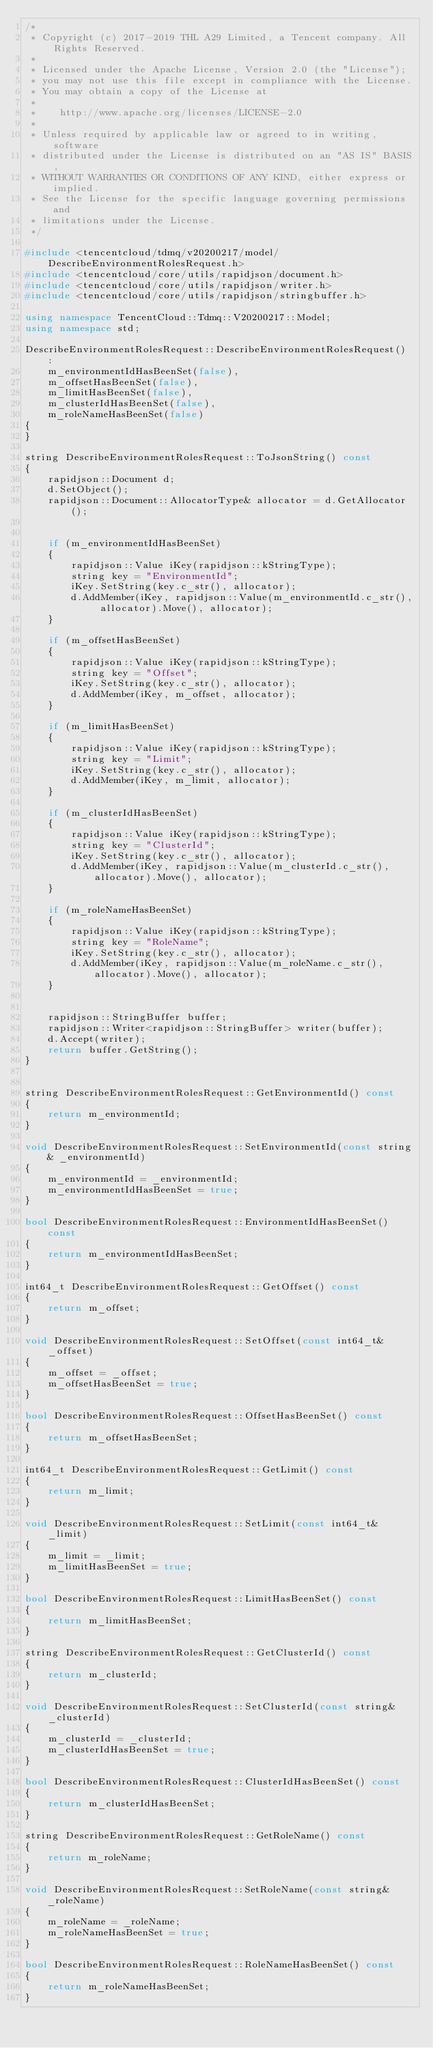<code> <loc_0><loc_0><loc_500><loc_500><_C++_>/*
 * Copyright (c) 2017-2019 THL A29 Limited, a Tencent company. All Rights Reserved.
 *
 * Licensed under the Apache License, Version 2.0 (the "License");
 * you may not use this file except in compliance with the License.
 * You may obtain a copy of the License at
 *
 *    http://www.apache.org/licenses/LICENSE-2.0
 *
 * Unless required by applicable law or agreed to in writing, software
 * distributed under the License is distributed on an "AS IS" BASIS,
 * WITHOUT WARRANTIES OR CONDITIONS OF ANY KIND, either express or implied.
 * See the License for the specific language governing permissions and
 * limitations under the License.
 */

#include <tencentcloud/tdmq/v20200217/model/DescribeEnvironmentRolesRequest.h>
#include <tencentcloud/core/utils/rapidjson/document.h>
#include <tencentcloud/core/utils/rapidjson/writer.h>
#include <tencentcloud/core/utils/rapidjson/stringbuffer.h>

using namespace TencentCloud::Tdmq::V20200217::Model;
using namespace std;

DescribeEnvironmentRolesRequest::DescribeEnvironmentRolesRequest() :
    m_environmentIdHasBeenSet(false),
    m_offsetHasBeenSet(false),
    m_limitHasBeenSet(false),
    m_clusterIdHasBeenSet(false),
    m_roleNameHasBeenSet(false)
{
}

string DescribeEnvironmentRolesRequest::ToJsonString() const
{
    rapidjson::Document d;
    d.SetObject();
    rapidjson::Document::AllocatorType& allocator = d.GetAllocator();


    if (m_environmentIdHasBeenSet)
    {
        rapidjson::Value iKey(rapidjson::kStringType);
        string key = "EnvironmentId";
        iKey.SetString(key.c_str(), allocator);
        d.AddMember(iKey, rapidjson::Value(m_environmentId.c_str(), allocator).Move(), allocator);
    }

    if (m_offsetHasBeenSet)
    {
        rapidjson::Value iKey(rapidjson::kStringType);
        string key = "Offset";
        iKey.SetString(key.c_str(), allocator);
        d.AddMember(iKey, m_offset, allocator);
    }

    if (m_limitHasBeenSet)
    {
        rapidjson::Value iKey(rapidjson::kStringType);
        string key = "Limit";
        iKey.SetString(key.c_str(), allocator);
        d.AddMember(iKey, m_limit, allocator);
    }

    if (m_clusterIdHasBeenSet)
    {
        rapidjson::Value iKey(rapidjson::kStringType);
        string key = "ClusterId";
        iKey.SetString(key.c_str(), allocator);
        d.AddMember(iKey, rapidjson::Value(m_clusterId.c_str(), allocator).Move(), allocator);
    }

    if (m_roleNameHasBeenSet)
    {
        rapidjson::Value iKey(rapidjson::kStringType);
        string key = "RoleName";
        iKey.SetString(key.c_str(), allocator);
        d.AddMember(iKey, rapidjson::Value(m_roleName.c_str(), allocator).Move(), allocator);
    }


    rapidjson::StringBuffer buffer;
    rapidjson::Writer<rapidjson::StringBuffer> writer(buffer);
    d.Accept(writer);
    return buffer.GetString();
}


string DescribeEnvironmentRolesRequest::GetEnvironmentId() const
{
    return m_environmentId;
}

void DescribeEnvironmentRolesRequest::SetEnvironmentId(const string& _environmentId)
{
    m_environmentId = _environmentId;
    m_environmentIdHasBeenSet = true;
}

bool DescribeEnvironmentRolesRequest::EnvironmentIdHasBeenSet() const
{
    return m_environmentIdHasBeenSet;
}

int64_t DescribeEnvironmentRolesRequest::GetOffset() const
{
    return m_offset;
}

void DescribeEnvironmentRolesRequest::SetOffset(const int64_t& _offset)
{
    m_offset = _offset;
    m_offsetHasBeenSet = true;
}

bool DescribeEnvironmentRolesRequest::OffsetHasBeenSet() const
{
    return m_offsetHasBeenSet;
}

int64_t DescribeEnvironmentRolesRequest::GetLimit() const
{
    return m_limit;
}

void DescribeEnvironmentRolesRequest::SetLimit(const int64_t& _limit)
{
    m_limit = _limit;
    m_limitHasBeenSet = true;
}

bool DescribeEnvironmentRolesRequest::LimitHasBeenSet() const
{
    return m_limitHasBeenSet;
}

string DescribeEnvironmentRolesRequest::GetClusterId() const
{
    return m_clusterId;
}

void DescribeEnvironmentRolesRequest::SetClusterId(const string& _clusterId)
{
    m_clusterId = _clusterId;
    m_clusterIdHasBeenSet = true;
}

bool DescribeEnvironmentRolesRequest::ClusterIdHasBeenSet() const
{
    return m_clusterIdHasBeenSet;
}

string DescribeEnvironmentRolesRequest::GetRoleName() const
{
    return m_roleName;
}

void DescribeEnvironmentRolesRequest::SetRoleName(const string& _roleName)
{
    m_roleName = _roleName;
    m_roleNameHasBeenSet = true;
}

bool DescribeEnvironmentRolesRequest::RoleNameHasBeenSet() const
{
    return m_roleNameHasBeenSet;
}


</code> 